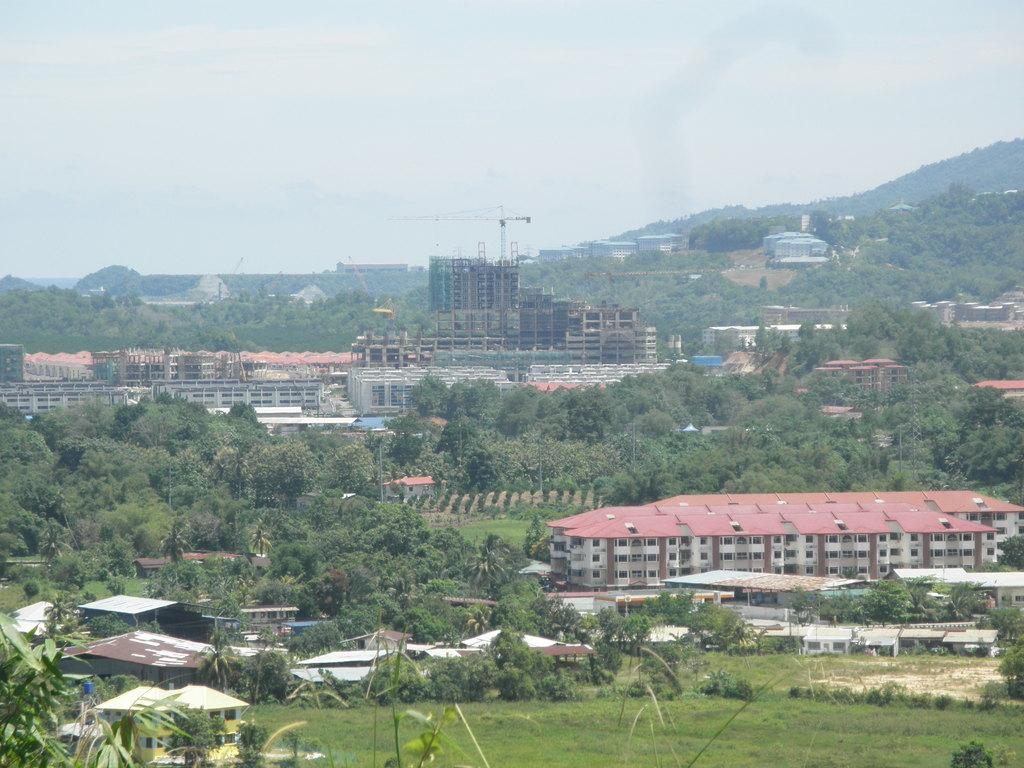What can be seen at the top of the image? The sky is visible towards the top of the image. What type of structures are present in the image? There are buildings in the image. What other natural elements can be seen in the image? There are trees and plants in the image. What type of ground cover is present towards the bottom of the image? Grass is present towards the bottom of the image. What is the impulse of the trees in the image? There is no indication of an impulse or any movement of the trees in the image; they are stationary. 